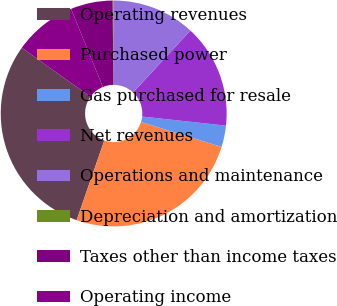Convert chart. <chart><loc_0><loc_0><loc_500><loc_500><pie_chart><fcel>Operating revenues<fcel>Purchased power<fcel>Gas purchased for resale<fcel>Net revenues<fcel>Operations and maintenance<fcel>Depreciation and amortization<fcel>Taxes other than income taxes<fcel>Operating income<nl><fcel>29.56%<fcel>25.53%<fcel>3.07%<fcel>14.84%<fcel>11.9%<fcel>0.13%<fcel>6.01%<fcel>8.96%<nl></chart> 